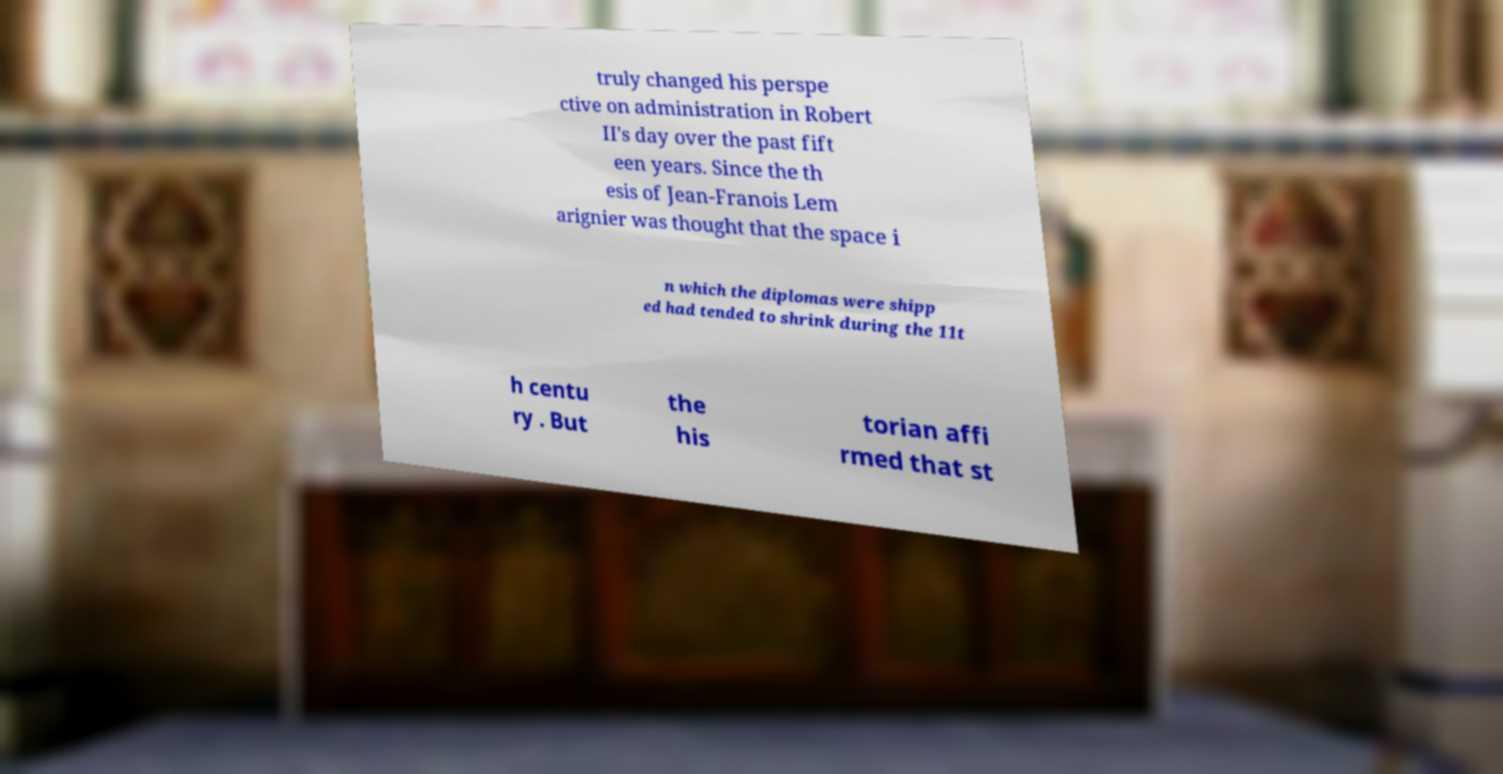Please read and relay the text visible in this image. What does it say? truly changed his perspe ctive on administration in Robert II's day over the past fift een years. Since the th esis of Jean-Franois Lem arignier was thought that the space i n which the diplomas were shipp ed had tended to shrink during the 11t h centu ry . But the his torian affi rmed that st 